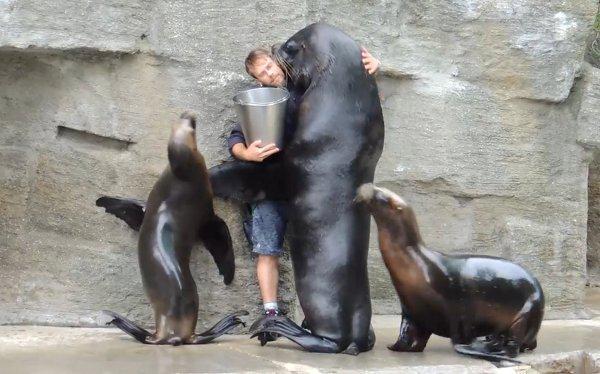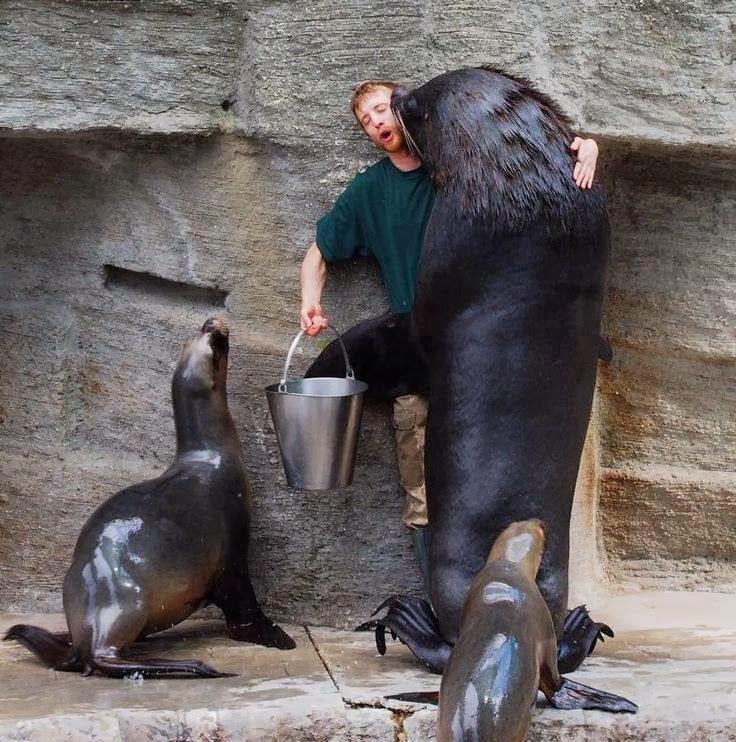The first image is the image on the left, the second image is the image on the right. Given the left and right images, does the statement "A man is holding a silver bucket as at least 3 seals gather around him." hold true? Answer yes or no. Yes. The first image is the image on the left, the second image is the image on the right. Evaluate the accuracy of this statement regarding the images: "In both images, an aquarist is being hugged and kissed by a sea lion.". Is it true? Answer yes or no. Yes. 